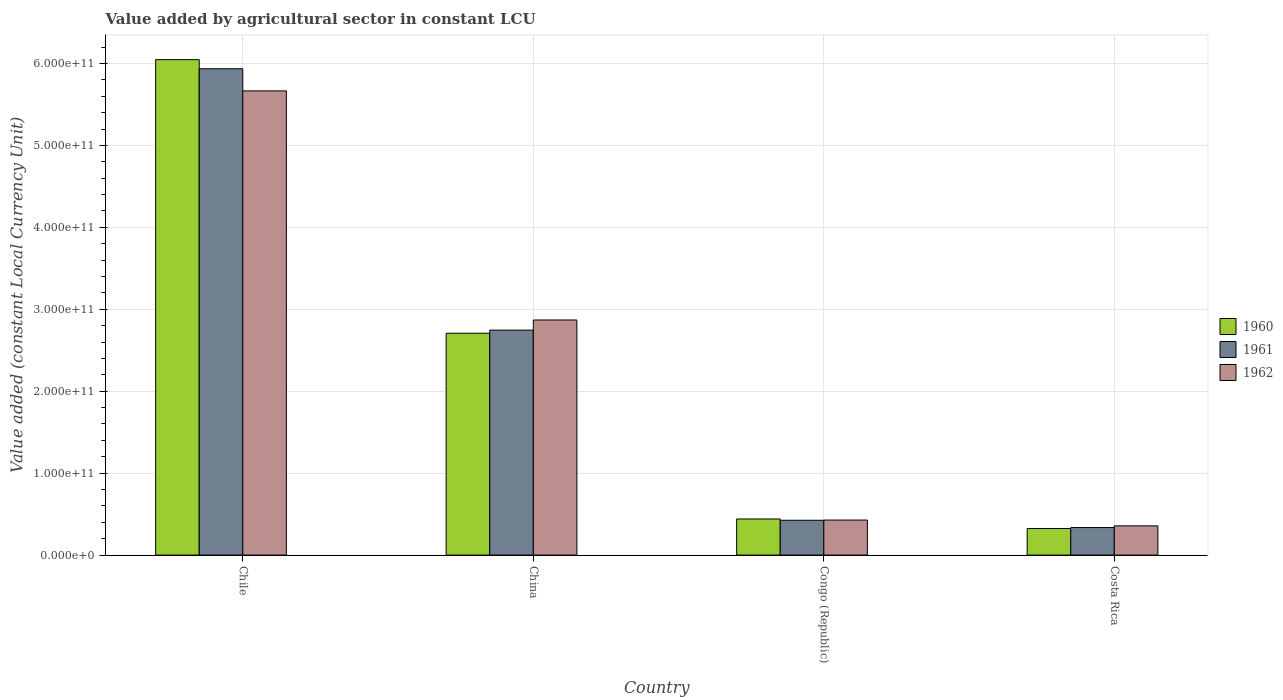How many bars are there on the 4th tick from the left?
Offer a terse response. 3. How many bars are there on the 1st tick from the right?
Your answer should be very brief. 3. In how many cases, is the number of bars for a given country not equal to the number of legend labels?
Provide a succinct answer. 0. What is the value added by agricultural sector in 1962 in Costa Rica?
Your response must be concise. 3.57e+1. Across all countries, what is the maximum value added by agricultural sector in 1961?
Offer a terse response. 5.94e+11. Across all countries, what is the minimum value added by agricultural sector in 1960?
Ensure brevity in your answer.  3.24e+1. In which country was the value added by agricultural sector in 1961 maximum?
Provide a succinct answer. Chile. In which country was the value added by agricultural sector in 1960 minimum?
Keep it short and to the point. Costa Rica. What is the total value added by agricultural sector in 1960 in the graph?
Offer a terse response. 9.52e+11. What is the difference between the value added by agricultural sector in 1962 in China and that in Congo (Republic)?
Provide a succinct answer. 2.44e+11. What is the difference between the value added by agricultural sector in 1960 in China and the value added by agricultural sector in 1961 in Costa Rica?
Give a very brief answer. 2.37e+11. What is the average value added by agricultural sector in 1960 per country?
Ensure brevity in your answer.  2.38e+11. What is the difference between the value added by agricultural sector of/in 1962 and value added by agricultural sector of/in 1961 in China?
Provide a succinct answer. 1.24e+1. In how many countries, is the value added by agricultural sector in 1962 greater than 100000000000 LCU?
Your response must be concise. 2. What is the ratio of the value added by agricultural sector in 1962 in Chile to that in China?
Provide a succinct answer. 1.97. Is the value added by agricultural sector in 1961 in China less than that in Costa Rica?
Offer a very short reply. No. Is the difference between the value added by agricultural sector in 1962 in Chile and China greater than the difference between the value added by agricultural sector in 1961 in Chile and China?
Provide a short and direct response. No. What is the difference between the highest and the second highest value added by agricultural sector in 1960?
Keep it short and to the point. -3.34e+11. What is the difference between the highest and the lowest value added by agricultural sector in 1961?
Keep it short and to the point. 5.60e+11. In how many countries, is the value added by agricultural sector in 1961 greater than the average value added by agricultural sector in 1961 taken over all countries?
Provide a succinct answer. 2. Is the sum of the value added by agricultural sector in 1962 in China and Costa Rica greater than the maximum value added by agricultural sector in 1961 across all countries?
Provide a short and direct response. No. What does the 3rd bar from the left in Congo (Republic) represents?
Offer a very short reply. 1962. Is it the case that in every country, the sum of the value added by agricultural sector in 1962 and value added by agricultural sector in 1960 is greater than the value added by agricultural sector in 1961?
Keep it short and to the point. Yes. What is the difference between two consecutive major ticks on the Y-axis?
Give a very brief answer. 1.00e+11. Are the values on the major ticks of Y-axis written in scientific E-notation?
Provide a succinct answer. Yes. Does the graph contain any zero values?
Give a very brief answer. No. Does the graph contain grids?
Keep it short and to the point. Yes. How many legend labels are there?
Make the answer very short. 3. How are the legend labels stacked?
Keep it short and to the point. Vertical. What is the title of the graph?
Your response must be concise. Value added by agricultural sector in constant LCU. Does "1972" appear as one of the legend labels in the graph?
Keep it short and to the point. No. What is the label or title of the X-axis?
Make the answer very short. Country. What is the label or title of the Y-axis?
Ensure brevity in your answer.  Value added (constant Local Currency Unit). What is the Value added (constant Local Currency Unit) in 1960 in Chile?
Offer a terse response. 6.05e+11. What is the Value added (constant Local Currency Unit) in 1961 in Chile?
Ensure brevity in your answer.  5.94e+11. What is the Value added (constant Local Currency Unit) of 1962 in Chile?
Offer a very short reply. 5.67e+11. What is the Value added (constant Local Currency Unit) in 1960 in China?
Your answer should be very brief. 2.71e+11. What is the Value added (constant Local Currency Unit) of 1961 in China?
Provide a succinct answer. 2.75e+11. What is the Value added (constant Local Currency Unit) of 1962 in China?
Offer a very short reply. 2.87e+11. What is the Value added (constant Local Currency Unit) in 1960 in Congo (Republic)?
Keep it short and to the point. 4.41e+1. What is the Value added (constant Local Currency Unit) in 1961 in Congo (Republic)?
Provide a short and direct response. 4.25e+1. What is the Value added (constant Local Currency Unit) in 1962 in Congo (Republic)?
Keep it short and to the point. 4.27e+1. What is the Value added (constant Local Currency Unit) in 1960 in Costa Rica?
Your response must be concise. 3.24e+1. What is the Value added (constant Local Currency Unit) in 1961 in Costa Rica?
Ensure brevity in your answer.  3.36e+1. What is the Value added (constant Local Currency Unit) of 1962 in Costa Rica?
Make the answer very short. 3.57e+1. Across all countries, what is the maximum Value added (constant Local Currency Unit) of 1960?
Provide a succinct answer. 6.05e+11. Across all countries, what is the maximum Value added (constant Local Currency Unit) in 1961?
Your answer should be compact. 5.94e+11. Across all countries, what is the maximum Value added (constant Local Currency Unit) in 1962?
Provide a succinct answer. 5.67e+11. Across all countries, what is the minimum Value added (constant Local Currency Unit) in 1960?
Give a very brief answer. 3.24e+1. Across all countries, what is the minimum Value added (constant Local Currency Unit) in 1961?
Provide a short and direct response. 3.36e+1. Across all countries, what is the minimum Value added (constant Local Currency Unit) of 1962?
Ensure brevity in your answer.  3.57e+1. What is the total Value added (constant Local Currency Unit) in 1960 in the graph?
Offer a terse response. 9.52e+11. What is the total Value added (constant Local Currency Unit) in 1961 in the graph?
Your answer should be compact. 9.44e+11. What is the total Value added (constant Local Currency Unit) of 1962 in the graph?
Offer a terse response. 9.32e+11. What is the difference between the Value added (constant Local Currency Unit) of 1960 in Chile and that in China?
Offer a terse response. 3.34e+11. What is the difference between the Value added (constant Local Currency Unit) of 1961 in Chile and that in China?
Offer a very short reply. 3.19e+11. What is the difference between the Value added (constant Local Currency Unit) in 1962 in Chile and that in China?
Keep it short and to the point. 2.80e+11. What is the difference between the Value added (constant Local Currency Unit) in 1960 in Chile and that in Congo (Republic)?
Keep it short and to the point. 5.61e+11. What is the difference between the Value added (constant Local Currency Unit) in 1961 in Chile and that in Congo (Republic)?
Keep it short and to the point. 5.51e+11. What is the difference between the Value added (constant Local Currency Unit) of 1962 in Chile and that in Congo (Republic)?
Your response must be concise. 5.24e+11. What is the difference between the Value added (constant Local Currency Unit) of 1960 in Chile and that in Costa Rica?
Provide a succinct answer. 5.72e+11. What is the difference between the Value added (constant Local Currency Unit) of 1961 in Chile and that in Costa Rica?
Your response must be concise. 5.60e+11. What is the difference between the Value added (constant Local Currency Unit) in 1962 in Chile and that in Costa Rica?
Your answer should be compact. 5.31e+11. What is the difference between the Value added (constant Local Currency Unit) of 1960 in China and that in Congo (Republic)?
Provide a short and direct response. 2.27e+11. What is the difference between the Value added (constant Local Currency Unit) of 1961 in China and that in Congo (Republic)?
Ensure brevity in your answer.  2.32e+11. What is the difference between the Value added (constant Local Currency Unit) in 1962 in China and that in Congo (Republic)?
Offer a very short reply. 2.44e+11. What is the difference between the Value added (constant Local Currency Unit) of 1960 in China and that in Costa Rica?
Provide a short and direct response. 2.38e+11. What is the difference between the Value added (constant Local Currency Unit) of 1961 in China and that in Costa Rica?
Your response must be concise. 2.41e+11. What is the difference between the Value added (constant Local Currency Unit) in 1962 in China and that in Costa Rica?
Keep it short and to the point. 2.51e+11. What is the difference between the Value added (constant Local Currency Unit) in 1960 in Congo (Republic) and that in Costa Rica?
Your answer should be very brief. 1.17e+1. What is the difference between the Value added (constant Local Currency Unit) in 1961 in Congo (Republic) and that in Costa Rica?
Your answer should be compact. 8.89e+09. What is the difference between the Value added (constant Local Currency Unit) in 1962 in Congo (Republic) and that in Costa Rica?
Your answer should be compact. 7.08e+09. What is the difference between the Value added (constant Local Currency Unit) of 1960 in Chile and the Value added (constant Local Currency Unit) of 1961 in China?
Your answer should be compact. 3.30e+11. What is the difference between the Value added (constant Local Currency Unit) in 1960 in Chile and the Value added (constant Local Currency Unit) in 1962 in China?
Your answer should be very brief. 3.18e+11. What is the difference between the Value added (constant Local Currency Unit) of 1961 in Chile and the Value added (constant Local Currency Unit) of 1962 in China?
Offer a very short reply. 3.07e+11. What is the difference between the Value added (constant Local Currency Unit) of 1960 in Chile and the Value added (constant Local Currency Unit) of 1961 in Congo (Republic)?
Ensure brevity in your answer.  5.62e+11. What is the difference between the Value added (constant Local Currency Unit) of 1960 in Chile and the Value added (constant Local Currency Unit) of 1962 in Congo (Republic)?
Your answer should be very brief. 5.62e+11. What is the difference between the Value added (constant Local Currency Unit) in 1961 in Chile and the Value added (constant Local Currency Unit) in 1962 in Congo (Republic)?
Make the answer very short. 5.51e+11. What is the difference between the Value added (constant Local Currency Unit) in 1960 in Chile and the Value added (constant Local Currency Unit) in 1961 in Costa Rica?
Your answer should be very brief. 5.71e+11. What is the difference between the Value added (constant Local Currency Unit) in 1960 in Chile and the Value added (constant Local Currency Unit) in 1962 in Costa Rica?
Your response must be concise. 5.69e+11. What is the difference between the Value added (constant Local Currency Unit) in 1961 in Chile and the Value added (constant Local Currency Unit) in 1962 in Costa Rica?
Your response must be concise. 5.58e+11. What is the difference between the Value added (constant Local Currency Unit) in 1960 in China and the Value added (constant Local Currency Unit) in 1961 in Congo (Republic)?
Keep it short and to the point. 2.28e+11. What is the difference between the Value added (constant Local Currency Unit) in 1960 in China and the Value added (constant Local Currency Unit) in 1962 in Congo (Republic)?
Ensure brevity in your answer.  2.28e+11. What is the difference between the Value added (constant Local Currency Unit) in 1961 in China and the Value added (constant Local Currency Unit) in 1962 in Congo (Republic)?
Offer a terse response. 2.32e+11. What is the difference between the Value added (constant Local Currency Unit) of 1960 in China and the Value added (constant Local Currency Unit) of 1961 in Costa Rica?
Provide a short and direct response. 2.37e+11. What is the difference between the Value added (constant Local Currency Unit) in 1960 in China and the Value added (constant Local Currency Unit) in 1962 in Costa Rica?
Your answer should be compact. 2.35e+11. What is the difference between the Value added (constant Local Currency Unit) of 1961 in China and the Value added (constant Local Currency Unit) of 1962 in Costa Rica?
Ensure brevity in your answer.  2.39e+11. What is the difference between the Value added (constant Local Currency Unit) of 1960 in Congo (Republic) and the Value added (constant Local Currency Unit) of 1961 in Costa Rica?
Give a very brief answer. 1.05e+1. What is the difference between the Value added (constant Local Currency Unit) of 1960 in Congo (Republic) and the Value added (constant Local Currency Unit) of 1962 in Costa Rica?
Keep it short and to the point. 8.40e+09. What is the difference between the Value added (constant Local Currency Unit) of 1961 in Congo (Republic) and the Value added (constant Local Currency Unit) of 1962 in Costa Rica?
Provide a short and direct response. 6.83e+09. What is the average Value added (constant Local Currency Unit) of 1960 per country?
Give a very brief answer. 2.38e+11. What is the average Value added (constant Local Currency Unit) of 1961 per country?
Provide a short and direct response. 2.36e+11. What is the average Value added (constant Local Currency Unit) in 1962 per country?
Provide a short and direct response. 2.33e+11. What is the difference between the Value added (constant Local Currency Unit) in 1960 and Value added (constant Local Currency Unit) in 1961 in Chile?
Keep it short and to the point. 1.11e+1. What is the difference between the Value added (constant Local Currency Unit) in 1960 and Value added (constant Local Currency Unit) in 1962 in Chile?
Provide a short and direct response. 3.82e+1. What is the difference between the Value added (constant Local Currency Unit) of 1961 and Value added (constant Local Currency Unit) of 1962 in Chile?
Keep it short and to the point. 2.70e+1. What is the difference between the Value added (constant Local Currency Unit) in 1960 and Value added (constant Local Currency Unit) in 1961 in China?
Make the answer very short. -3.79e+09. What is the difference between the Value added (constant Local Currency Unit) of 1960 and Value added (constant Local Currency Unit) of 1962 in China?
Give a very brief answer. -1.61e+1. What is the difference between the Value added (constant Local Currency Unit) in 1961 and Value added (constant Local Currency Unit) in 1962 in China?
Your answer should be very brief. -1.24e+1. What is the difference between the Value added (constant Local Currency Unit) in 1960 and Value added (constant Local Currency Unit) in 1961 in Congo (Republic)?
Keep it short and to the point. 1.57e+09. What is the difference between the Value added (constant Local Currency Unit) of 1960 and Value added (constant Local Currency Unit) of 1962 in Congo (Republic)?
Your answer should be compact. 1.32e+09. What is the difference between the Value added (constant Local Currency Unit) in 1961 and Value added (constant Local Currency Unit) in 1962 in Congo (Republic)?
Ensure brevity in your answer.  -2.56e+08. What is the difference between the Value added (constant Local Currency Unit) of 1960 and Value added (constant Local Currency Unit) of 1961 in Costa Rica?
Your answer should be very brief. -1.19e+09. What is the difference between the Value added (constant Local Currency Unit) in 1960 and Value added (constant Local Currency Unit) in 1962 in Costa Rica?
Provide a short and direct response. -3.25e+09. What is the difference between the Value added (constant Local Currency Unit) in 1961 and Value added (constant Local Currency Unit) in 1962 in Costa Rica?
Your answer should be very brief. -2.06e+09. What is the ratio of the Value added (constant Local Currency Unit) in 1960 in Chile to that in China?
Keep it short and to the point. 2.23. What is the ratio of the Value added (constant Local Currency Unit) of 1961 in Chile to that in China?
Offer a terse response. 2.16. What is the ratio of the Value added (constant Local Currency Unit) of 1962 in Chile to that in China?
Your answer should be very brief. 1.97. What is the ratio of the Value added (constant Local Currency Unit) in 1960 in Chile to that in Congo (Republic)?
Offer a terse response. 13.73. What is the ratio of the Value added (constant Local Currency Unit) of 1961 in Chile to that in Congo (Republic)?
Ensure brevity in your answer.  13.97. What is the ratio of the Value added (constant Local Currency Unit) in 1962 in Chile to that in Congo (Republic)?
Provide a succinct answer. 13.26. What is the ratio of the Value added (constant Local Currency Unit) of 1960 in Chile to that in Costa Rica?
Keep it short and to the point. 18.66. What is the ratio of the Value added (constant Local Currency Unit) of 1961 in Chile to that in Costa Rica?
Make the answer very short. 17.67. What is the ratio of the Value added (constant Local Currency Unit) in 1962 in Chile to that in Costa Rica?
Provide a succinct answer. 15.89. What is the ratio of the Value added (constant Local Currency Unit) in 1960 in China to that in Congo (Republic)?
Give a very brief answer. 6.15. What is the ratio of the Value added (constant Local Currency Unit) of 1961 in China to that in Congo (Republic)?
Your response must be concise. 6.46. What is the ratio of the Value added (constant Local Currency Unit) of 1962 in China to that in Congo (Republic)?
Provide a short and direct response. 6.71. What is the ratio of the Value added (constant Local Currency Unit) in 1960 in China to that in Costa Rica?
Your answer should be very brief. 8.36. What is the ratio of the Value added (constant Local Currency Unit) in 1961 in China to that in Costa Rica?
Make the answer very short. 8.17. What is the ratio of the Value added (constant Local Currency Unit) of 1962 in China to that in Costa Rica?
Make the answer very short. 8.05. What is the ratio of the Value added (constant Local Currency Unit) of 1960 in Congo (Republic) to that in Costa Rica?
Keep it short and to the point. 1.36. What is the ratio of the Value added (constant Local Currency Unit) of 1961 in Congo (Republic) to that in Costa Rica?
Provide a succinct answer. 1.26. What is the ratio of the Value added (constant Local Currency Unit) of 1962 in Congo (Republic) to that in Costa Rica?
Keep it short and to the point. 1.2. What is the difference between the highest and the second highest Value added (constant Local Currency Unit) in 1960?
Offer a very short reply. 3.34e+11. What is the difference between the highest and the second highest Value added (constant Local Currency Unit) of 1961?
Offer a very short reply. 3.19e+11. What is the difference between the highest and the second highest Value added (constant Local Currency Unit) of 1962?
Give a very brief answer. 2.80e+11. What is the difference between the highest and the lowest Value added (constant Local Currency Unit) in 1960?
Offer a terse response. 5.72e+11. What is the difference between the highest and the lowest Value added (constant Local Currency Unit) of 1961?
Your response must be concise. 5.60e+11. What is the difference between the highest and the lowest Value added (constant Local Currency Unit) of 1962?
Keep it short and to the point. 5.31e+11. 